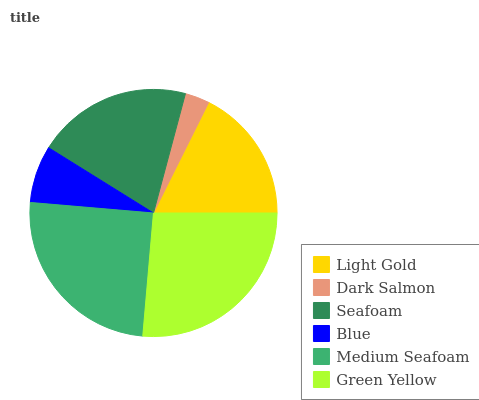Is Dark Salmon the minimum?
Answer yes or no. Yes. Is Green Yellow the maximum?
Answer yes or no. Yes. Is Seafoam the minimum?
Answer yes or no. No. Is Seafoam the maximum?
Answer yes or no. No. Is Seafoam greater than Dark Salmon?
Answer yes or no. Yes. Is Dark Salmon less than Seafoam?
Answer yes or no. Yes. Is Dark Salmon greater than Seafoam?
Answer yes or no. No. Is Seafoam less than Dark Salmon?
Answer yes or no. No. Is Seafoam the high median?
Answer yes or no. Yes. Is Light Gold the low median?
Answer yes or no. Yes. Is Medium Seafoam the high median?
Answer yes or no. No. Is Green Yellow the low median?
Answer yes or no. No. 